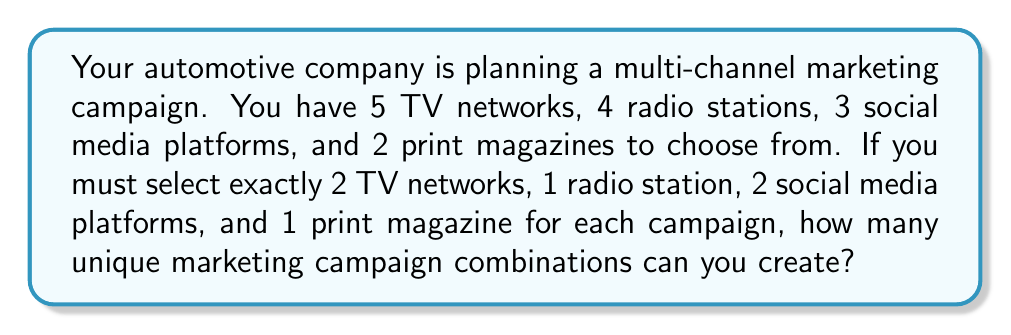Can you answer this question? Let's break this down step-by-step using the multiplication principle of counting:

1. Selecting 2 TV networks from 5:
   This is a combination problem, as the order doesn't matter.
   $${5 \choose 2} = \frac{5!}{2!(5-2)!} = \frac{5 \cdot 4}{2 \cdot 1} = 10$$

2. Selecting 1 radio station from 4:
   This is a simple choice of 1 from 4.
   $$4$$

3. Selecting 2 social media platforms from 3:
   Another combination problem.
   $${3 \choose 2} = \frac{3!}{2!(3-2)!} = \frac{3 \cdot 2}{2 \cdot 1} = 3$$

4. Selecting 1 print magazine from 2:
   A simple choice of 1 from 2.
   $$2$$

Now, we apply the multiplication principle. The total number of unique combinations is the product of all these individual choices:

$$10 \cdot 4 \cdot 3 \cdot 2 = 240$$

Therefore, you can create 240 unique marketing campaign combinations.
Answer: 240 